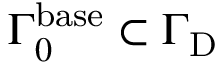<formula> <loc_0><loc_0><loc_500><loc_500>{ \Gamma } _ { 0 } ^ { b a s e } \subset { \Gamma } _ { D }</formula> 